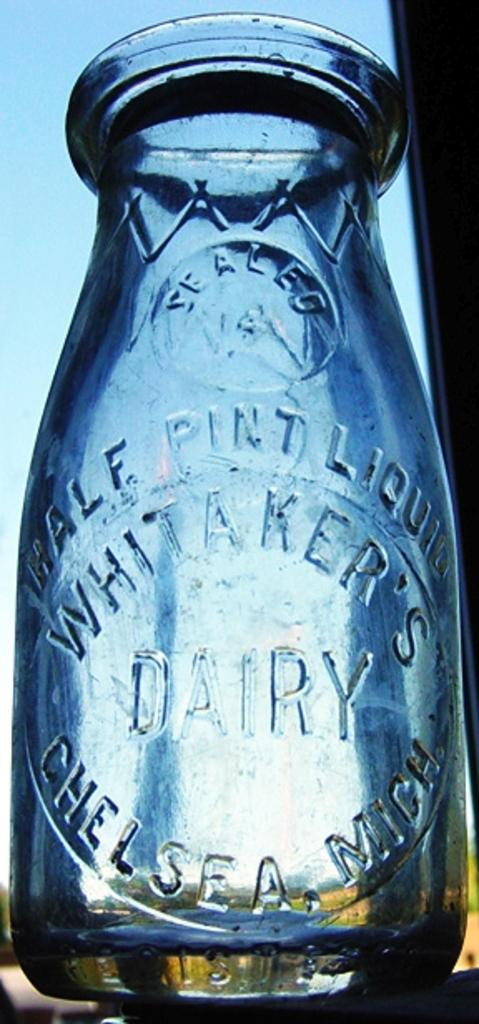Provide a one-sentence caption for the provided image. A milk jug from the Whitaker's dairy company. 